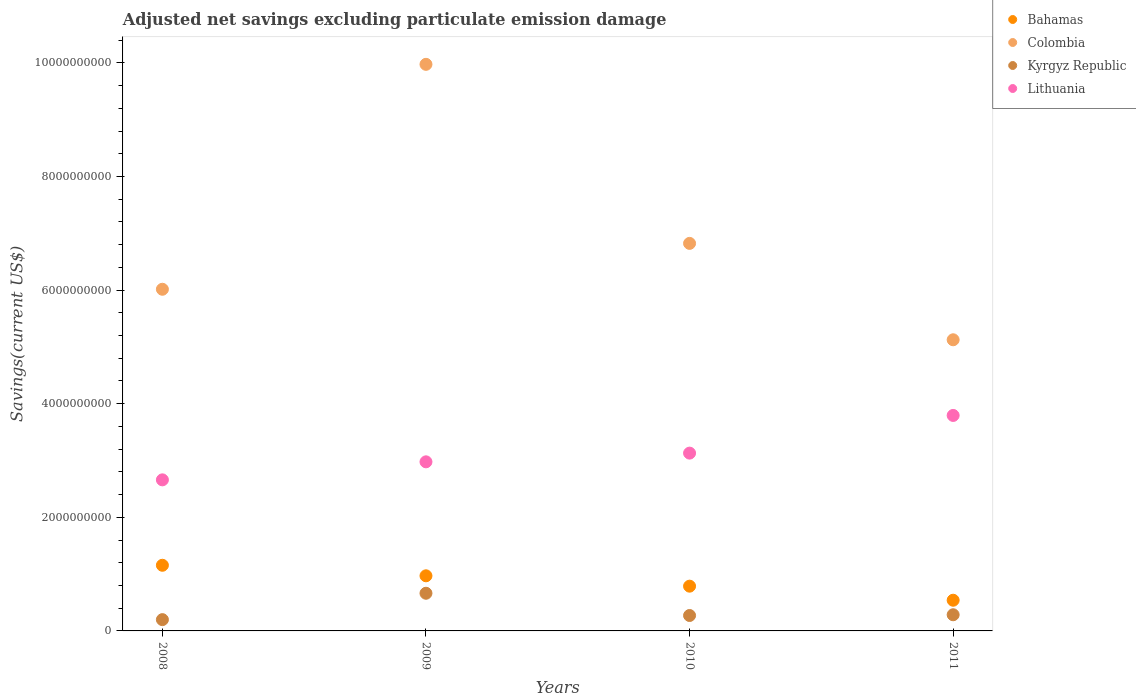What is the adjusted net savings in Lithuania in 2011?
Offer a very short reply. 3.79e+09. Across all years, what is the maximum adjusted net savings in Lithuania?
Give a very brief answer. 3.79e+09. Across all years, what is the minimum adjusted net savings in Kyrgyz Republic?
Ensure brevity in your answer.  1.99e+08. In which year was the adjusted net savings in Lithuania maximum?
Offer a terse response. 2011. What is the total adjusted net savings in Bahamas in the graph?
Make the answer very short. 3.45e+09. What is the difference between the adjusted net savings in Colombia in 2010 and that in 2011?
Offer a very short reply. 1.70e+09. What is the difference between the adjusted net savings in Kyrgyz Republic in 2011 and the adjusted net savings in Colombia in 2010?
Make the answer very short. -6.54e+09. What is the average adjusted net savings in Colombia per year?
Offer a terse response. 6.98e+09. In the year 2011, what is the difference between the adjusted net savings in Lithuania and adjusted net savings in Bahamas?
Make the answer very short. 3.25e+09. What is the ratio of the adjusted net savings in Lithuania in 2009 to that in 2010?
Keep it short and to the point. 0.95. What is the difference between the highest and the second highest adjusted net savings in Colombia?
Your answer should be very brief. 3.15e+09. What is the difference between the highest and the lowest adjusted net savings in Colombia?
Give a very brief answer. 4.85e+09. In how many years, is the adjusted net savings in Bahamas greater than the average adjusted net savings in Bahamas taken over all years?
Make the answer very short. 2. Is it the case that in every year, the sum of the adjusted net savings in Colombia and adjusted net savings in Kyrgyz Republic  is greater than the adjusted net savings in Bahamas?
Offer a very short reply. Yes. Is the adjusted net savings in Kyrgyz Republic strictly greater than the adjusted net savings in Colombia over the years?
Provide a short and direct response. No. How many dotlines are there?
Your response must be concise. 4. How many years are there in the graph?
Provide a succinct answer. 4. Are the values on the major ticks of Y-axis written in scientific E-notation?
Your response must be concise. No. Does the graph contain grids?
Offer a terse response. No. How many legend labels are there?
Offer a very short reply. 4. How are the legend labels stacked?
Offer a terse response. Vertical. What is the title of the graph?
Offer a terse response. Adjusted net savings excluding particulate emission damage. Does "Guam" appear as one of the legend labels in the graph?
Provide a succinct answer. No. What is the label or title of the Y-axis?
Give a very brief answer. Savings(current US$). What is the Savings(current US$) of Bahamas in 2008?
Provide a short and direct response. 1.16e+09. What is the Savings(current US$) of Colombia in 2008?
Provide a short and direct response. 6.01e+09. What is the Savings(current US$) of Kyrgyz Republic in 2008?
Your answer should be very brief. 1.99e+08. What is the Savings(current US$) of Lithuania in 2008?
Give a very brief answer. 2.66e+09. What is the Savings(current US$) in Bahamas in 2009?
Your response must be concise. 9.70e+08. What is the Savings(current US$) in Colombia in 2009?
Keep it short and to the point. 9.97e+09. What is the Savings(current US$) of Kyrgyz Republic in 2009?
Your response must be concise. 6.63e+08. What is the Savings(current US$) in Lithuania in 2009?
Provide a succinct answer. 2.98e+09. What is the Savings(current US$) in Bahamas in 2010?
Your answer should be very brief. 7.88e+08. What is the Savings(current US$) of Colombia in 2010?
Keep it short and to the point. 6.82e+09. What is the Savings(current US$) of Kyrgyz Republic in 2010?
Offer a very short reply. 2.71e+08. What is the Savings(current US$) in Lithuania in 2010?
Give a very brief answer. 3.13e+09. What is the Savings(current US$) of Bahamas in 2011?
Keep it short and to the point. 5.40e+08. What is the Savings(current US$) in Colombia in 2011?
Keep it short and to the point. 5.12e+09. What is the Savings(current US$) in Kyrgyz Republic in 2011?
Your answer should be compact. 2.85e+08. What is the Savings(current US$) of Lithuania in 2011?
Offer a terse response. 3.79e+09. Across all years, what is the maximum Savings(current US$) in Bahamas?
Give a very brief answer. 1.16e+09. Across all years, what is the maximum Savings(current US$) of Colombia?
Ensure brevity in your answer.  9.97e+09. Across all years, what is the maximum Savings(current US$) of Kyrgyz Republic?
Ensure brevity in your answer.  6.63e+08. Across all years, what is the maximum Savings(current US$) of Lithuania?
Ensure brevity in your answer.  3.79e+09. Across all years, what is the minimum Savings(current US$) of Bahamas?
Your answer should be very brief. 5.40e+08. Across all years, what is the minimum Savings(current US$) of Colombia?
Your answer should be compact. 5.12e+09. Across all years, what is the minimum Savings(current US$) of Kyrgyz Republic?
Your answer should be compact. 1.99e+08. Across all years, what is the minimum Savings(current US$) in Lithuania?
Provide a short and direct response. 2.66e+09. What is the total Savings(current US$) in Bahamas in the graph?
Give a very brief answer. 3.45e+09. What is the total Savings(current US$) of Colombia in the graph?
Provide a succinct answer. 2.79e+1. What is the total Savings(current US$) of Kyrgyz Republic in the graph?
Provide a short and direct response. 1.42e+09. What is the total Savings(current US$) of Lithuania in the graph?
Your answer should be very brief. 1.26e+1. What is the difference between the Savings(current US$) in Bahamas in 2008 and that in 2009?
Provide a short and direct response. 1.85e+08. What is the difference between the Savings(current US$) of Colombia in 2008 and that in 2009?
Offer a terse response. -3.96e+09. What is the difference between the Savings(current US$) in Kyrgyz Republic in 2008 and that in 2009?
Make the answer very short. -4.65e+08. What is the difference between the Savings(current US$) of Lithuania in 2008 and that in 2009?
Provide a short and direct response. -3.17e+08. What is the difference between the Savings(current US$) of Bahamas in 2008 and that in 2010?
Keep it short and to the point. 3.68e+08. What is the difference between the Savings(current US$) in Colombia in 2008 and that in 2010?
Your answer should be compact. -8.08e+08. What is the difference between the Savings(current US$) of Kyrgyz Republic in 2008 and that in 2010?
Your answer should be compact. -7.28e+07. What is the difference between the Savings(current US$) in Lithuania in 2008 and that in 2010?
Your answer should be very brief. -4.70e+08. What is the difference between the Savings(current US$) of Bahamas in 2008 and that in 2011?
Offer a terse response. 6.15e+08. What is the difference between the Savings(current US$) in Colombia in 2008 and that in 2011?
Make the answer very short. 8.89e+08. What is the difference between the Savings(current US$) of Kyrgyz Republic in 2008 and that in 2011?
Provide a short and direct response. -8.60e+07. What is the difference between the Savings(current US$) in Lithuania in 2008 and that in 2011?
Give a very brief answer. -1.13e+09. What is the difference between the Savings(current US$) in Bahamas in 2009 and that in 2010?
Your response must be concise. 1.82e+08. What is the difference between the Savings(current US$) in Colombia in 2009 and that in 2010?
Give a very brief answer. 3.15e+09. What is the difference between the Savings(current US$) in Kyrgyz Republic in 2009 and that in 2010?
Your answer should be compact. 3.92e+08. What is the difference between the Savings(current US$) of Lithuania in 2009 and that in 2010?
Provide a short and direct response. -1.53e+08. What is the difference between the Savings(current US$) of Bahamas in 2009 and that in 2011?
Provide a succinct answer. 4.30e+08. What is the difference between the Savings(current US$) of Colombia in 2009 and that in 2011?
Your response must be concise. 4.85e+09. What is the difference between the Savings(current US$) of Kyrgyz Republic in 2009 and that in 2011?
Provide a short and direct response. 3.78e+08. What is the difference between the Savings(current US$) of Lithuania in 2009 and that in 2011?
Make the answer very short. -8.17e+08. What is the difference between the Savings(current US$) in Bahamas in 2010 and that in 2011?
Keep it short and to the point. 2.48e+08. What is the difference between the Savings(current US$) of Colombia in 2010 and that in 2011?
Keep it short and to the point. 1.70e+09. What is the difference between the Savings(current US$) in Kyrgyz Republic in 2010 and that in 2011?
Provide a succinct answer. -1.32e+07. What is the difference between the Savings(current US$) in Lithuania in 2010 and that in 2011?
Provide a succinct answer. -6.63e+08. What is the difference between the Savings(current US$) of Bahamas in 2008 and the Savings(current US$) of Colombia in 2009?
Give a very brief answer. -8.82e+09. What is the difference between the Savings(current US$) of Bahamas in 2008 and the Savings(current US$) of Kyrgyz Republic in 2009?
Give a very brief answer. 4.93e+08. What is the difference between the Savings(current US$) in Bahamas in 2008 and the Savings(current US$) in Lithuania in 2009?
Give a very brief answer. -1.82e+09. What is the difference between the Savings(current US$) in Colombia in 2008 and the Savings(current US$) in Kyrgyz Republic in 2009?
Provide a short and direct response. 5.35e+09. What is the difference between the Savings(current US$) in Colombia in 2008 and the Savings(current US$) in Lithuania in 2009?
Provide a succinct answer. 3.04e+09. What is the difference between the Savings(current US$) of Kyrgyz Republic in 2008 and the Savings(current US$) of Lithuania in 2009?
Your answer should be very brief. -2.78e+09. What is the difference between the Savings(current US$) of Bahamas in 2008 and the Savings(current US$) of Colombia in 2010?
Ensure brevity in your answer.  -5.67e+09. What is the difference between the Savings(current US$) in Bahamas in 2008 and the Savings(current US$) in Kyrgyz Republic in 2010?
Make the answer very short. 8.84e+08. What is the difference between the Savings(current US$) in Bahamas in 2008 and the Savings(current US$) in Lithuania in 2010?
Offer a very short reply. -1.97e+09. What is the difference between the Savings(current US$) of Colombia in 2008 and the Savings(current US$) of Kyrgyz Republic in 2010?
Provide a succinct answer. 5.74e+09. What is the difference between the Savings(current US$) in Colombia in 2008 and the Savings(current US$) in Lithuania in 2010?
Your answer should be very brief. 2.88e+09. What is the difference between the Savings(current US$) of Kyrgyz Republic in 2008 and the Savings(current US$) of Lithuania in 2010?
Offer a terse response. -2.93e+09. What is the difference between the Savings(current US$) of Bahamas in 2008 and the Savings(current US$) of Colombia in 2011?
Give a very brief answer. -3.97e+09. What is the difference between the Savings(current US$) of Bahamas in 2008 and the Savings(current US$) of Kyrgyz Republic in 2011?
Offer a very short reply. 8.71e+08. What is the difference between the Savings(current US$) of Bahamas in 2008 and the Savings(current US$) of Lithuania in 2011?
Provide a succinct answer. -2.64e+09. What is the difference between the Savings(current US$) in Colombia in 2008 and the Savings(current US$) in Kyrgyz Republic in 2011?
Offer a very short reply. 5.73e+09. What is the difference between the Savings(current US$) of Colombia in 2008 and the Savings(current US$) of Lithuania in 2011?
Keep it short and to the point. 2.22e+09. What is the difference between the Savings(current US$) of Kyrgyz Republic in 2008 and the Savings(current US$) of Lithuania in 2011?
Offer a terse response. -3.59e+09. What is the difference between the Savings(current US$) of Bahamas in 2009 and the Savings(current US$) of Colombia in 2010?
Offer a terse response. -5.85e+09. What is the difference between the Savings(current US$) of Bahamas in 2009 and the Savings(current US$) of Kyrgyz Republic in 2010?
Make the answer very short. 6.99e+08. What is the difference between the Savings(current US$) in Bahamas in 2009 and the Savings(current US$) in Lithuania in 2010?
Provide a short and direct response. -2.16e+09. What is the difference between the Savings(current US$) in Colombia in 2009 and the Savings(current US$) in Kyrgyz Republic in 2010?
Offer a terse response. 9.70e+09. What is the difference between the Savings(current US$) in Colombia in 2009 and the Savings(current US$) in Lithuania in 2010?
Your answer should be very brief. 6.84e+09. What is the difference between the Savings(current US$) of Kyrgyz Republic in 2009 and the Savings(current US$) of Lithuania in 2010?
Offer a terse response. -2.47e+09. What is the difference between the Savings(current US$) of Bahamas in 2009 and the Savings(current US$) of Colombia in 2011?
Your answer should be compact. -4.15e+09. What is the difference between the Savings(current US$) of Bahamas in 2009 and the Savings(current US$) of Kyrgyz Republic in 2011?
Keep it short and to the point. 6.86e+08. What is the difference between the Savings(current US$) in Bahamas in 2009 and the Savings(current US$) in Lithuania in 2011?
Offer a very short reply. -2.82e+09. What is the difference between the Savings(current US$) in Colombia in 2009 and the Savings(current US$) in Kyrgyz Republic in 2011?
Provide a succinct answer. 9.69e+09. What is the difference between the Savings(current US$) of Colombia in 2009 and the Savings(current US$) of Lithuania in 2011?
Keep it short and to the point. 6.18e+09. What is the difference between the Savings(current US$) of Kyrgyz Republic in 2009 and the Savings(current US$) of Lithuania in 2011?
Provide a succinct answer. -3.13e+09. What is the difference between the Savings(current US$) in Bahamas in 2010 and the Savings(current US$) in Colombia in 2011?
Offer a very short reply. -4.34e+09. What is the difference between the Savings(current US$) of Bahamas in 2010 and the Savings(current US$) of Kyrgyz Republic in 2011?
Your answer should be compact. 5.03e+08. What is the difference between the Savings(current US$) in Bahamas in 2010 and the Savings(current US$) in Lithuania in 2011?
Your response must be concise. -3.01e+09. What is the difference between the Savings(current US$) of Colombia in 2010 and the Savings(current US$) of Kyrgyz Republic in 2011?
Offer a terse response. 6.54e+09. What is the difference between the Savings(current US$) in Colombia in 2010 and the Savings(current US$) in Lithuania in 2011?
Your answer should be very brief. 3.03e+09. What is the difference between the Savings(current US$) of Kyrgyz Republic in 2010 and the Savings(current US$) of Lithuania in 2011?
Your answer should be compact. -3.52e+09. What is the average Savings(current US$) in Bahamas per year?
Make the answer very short. 8.63e+08. What is the average Savings(current US$) in Colombia per year?
Your response must be concise. 6.98e+09. What is the average Savings(current US$) of Kyrgyz Republic per year?
Your answer should be compact. 3.54e+08. What is the average Savings(current US$) in Lithuania per year?
Provide a succinct answer. 3.14e+09. In the year 2008, what is the difference between the Savings(current US$) of Bahamas and Savings(current US$) of Colombia?
Your answer should be very brief. -4.86e+09. In the year 2008, what is the difference between the Savings(current US$) in Bahamas and Savings(current US$) in Kyrgyz Republic?
Make the answer very short. 9.57e+08. In the year 2008, what is the difference between the Savings(current US$) in Bahamas and Savings(current US$) in Lithuania?
Your response must be concise. -1.50e+09. In the year 2008, what is the difference between the Savings(current US$) in Colombia and Savings(current US$) in Kyrgyz Republic?
Offer a terse response. 5.82e+09. In the year 2008, what is the difference between the Savings(current US$) in Colombia and Savings(current US$) in Lithuania?
Your answer should be compact. 3.35e+09. In the year 2008, what is the difference between the Savings(current US$) of Kyrgyz Republic and Savings(current US$) of Lithuania?
Your response must be concise. -2.46e+09. In the year 2009, what is the difference between the Savings(current US$) in Bahamas and Savings(current US$) in Colombia?
Make the answer very short. -9.00e+09. In the year 2009, what is the difference between the Savings(current US$) in Bahamas and Savings(current US$) in Kyrgyz Republic?
Ensure brevity in your answer.  3.07e+08. In the year 2009, what is the difference between the Savings(current US$) in Bahamas and Savings(current US$) in Lithuania?
Make the answer very short. -2.01e+09. In the year 2009, what is the difference between the Savings(current US$) in Colombia and Savings(current US$) in Kyrgyz Republic?
Ensure brevity in your answer.  9.31e+09. In the year 2009, what is the difference between the Savings(current US$) in Colombia and Savings(current US$) in Lithuania?
Offer a very short reply. 7.00e+09. In the year 2009, what is the difference between the Savings(current US$) in Kyrgyz Republic and Savings(current US$) in Lithuania?
Ensure brevity in your answer.  -2.31e+09. In the year 2010, what is the difference between the Savings(current US$) in Bahamas and Savings(current US$) in Colombia?
Offer a terse response. -6.03e+09. In the year 2010, what is the difference between the Savings(current US$) in Bahamas and Savings(current US$) in Kyrgyz Republic?
Give a very brief answer. 5.16e+08. In the year 2010, what is the difference between the Savings(current US$) of Bahamas and Savings(current US$) of Lithuania?
Make the answer very short. -2.34e+09. In the year 2010, what is the difference between the Savings(current US$) of Colombia and Savings(current US$) of Kyrgyz Republic?
Keep it short and to the point. 6.55e+09. In the year 2010, what is the difference between the Savings(current US$) of Colombia and Savings(current US$) of Lithuania?
Offer a very short reply. 3.69e+09. In the year 2010, what is the difference between the Savings(current US$) of Kyrgyz Republic and Savings(current US$) of Lithuania?
Offer a very short reply. -2.86e+09. In the year 2011, what is the difference between the Savings(current US$) of Bahamas and Savings(current US$) of Colombia?
Your answer should be very brief. -4.58e+09. In the year 2011, what is the difference between the Savings(current US$) in Bahamas and Savings(current US$) in Kyrgyz Republic?
Make the answer very short. 2.56e+08. In the year 2011, what is the difference between the Savings(current US$) in Bahamas and Savings(current US$) in Lithuania?
Your answer should be very brief. -3.25e+09. In the year 2011, what is the difference between the Savings(current US$) of Colombia and Savings(current US$) of Kyrgyz Republic?
Provide a succinct answer. 4.84e+09. In the year 2011, what is the difference between the Savings(current US$) of Colombia and Savings(current US$) of Lithuania?
Your answer should be very brief. 1.33e+09. In the year 2011, what is the difference between the Savings(current US$) in Kyrgyz Republic and Savings(current US$) in Lithuania?
Your response must be concise. -3.51e+09. What is the ratio of the Savings(current US$) in Bahamas in 2008 to that in 2009?
Your answer should be compact. 1.19. What is the ratio of the Savings(current US$) of Colombia in 2008 to that in 2009?
Your response must be concise. 0.6. What is the ratio of the Savings(current US$) in Kyrgyz Republic in 2008 to that in 2009?
Provide a short and direct response. 0.3. What is the ratio of the Savings(current US$) in Lithuania in 2008 to that in 2009?
Make the answer very short. 0.89. What is the ratio of the Savings(current US$) of Bahamas in 2008 to that in 2010?
Provide a succinct answer. 1.47. What is the ratio of the Savings(current US$) in Colombia in 2008 to that in 2010?
Ensure brevity in your answer.  0.88. What is the ratio of the Savings(current US$) of Kyrgyz Republic in 2008 to that in 2010?
Give a very brief answer. 0.73. What is the ratio of the Savings(current US$) in Lithuania in 2008 to that in 2010?
Give a very brief answer. 0.85. What is the ratio of the Savings(current US$) of Bahamas in 2008 to that in 2011?
Ensure brevity in your answer.  2.14. What is the ratio of the Savings(current US$) of Colombia in 2008 to that in 2011?
Your answer should be compact. 1.17. What is the ratio of the Savings(current US$) in Kyrgyz Republic in 2008 to that in 2011?
Keep it short and to the point. 0.7. What is the ratio of the Savings(current US$) in Lithuania in 2008 to that in 2011?
Keep it short and to the point. 0.7. What is the ratio of the Savings(current US$) of Bahamas in 2009 to that in 2010?
Your response must be concise. 1.23. What is the ratio of the Savings(current US$) in Colombia in 2009 to that in 2010?
Make the answer very short. 1.46. What is the ratio of the Savings(current US$) in Kyrgyz Republic in 2009 to that in 2010?
Your answer should be compact. 2.44. What is the ratio of the Savings(current US$) in Lithuania in 2009 to that in 2010?
Provide a succinct answer. 0.95. What is the ratio of the Savings(current US$) in Bahamas in 2009 to that in 2011?
Provide a succinct answer. 1.8. What is the ratio of the Savings(current US$) of Colombia in 2009 to that in 2011?
Your answer should be very brief. 1.95. What is the ratio of the Savings(current US$) in Kyrgyz Republic in 2009 to that in 2011?
Ensure brevity in your answer.  2.33. What is the ratio of the Savings(current US$) of Lithuania in 2009 to that in 2011?
Your answer should be compact. 0.78. What is the ratio of the Savings(current US$) in Bahamas in 2010 to that in 2011?
Your answer should be compact. 1.46. What is the ratio of the Savings(current US$) of Colombia in 2010 to that in 2011?
Offer a terse response. 1.33. What is the ratio of the Savings(current US$) in Kyrgyz Republic in 2010 to that in 2011?
Make the answer very short. 0.95. What is the ratio of the Savings(current US$) of Lithuania in 2010 to that in 2011?
Give a very brief answer. 0.83. What is the difference between the highest and the second highest Savings(current US$) of Bahamas?
Keep it short and to the point. 1.85e+08. What is the difference between the highest and the second highest Savings(current US$) of Colombia?
Your answer should be very brief. 3.15e+09. What is the difference between the highest and the second highest Savings(current US$) in Kyrgyz Republic?
Keep it short and to the point. 3.78e+08. What is the difference between the highest and the second highest Savings(current US$) in Lithuania?
Offer a terse response. 6.63e+08. What is the difference between the highest and the lowest Savings(current US$) of Bahamas?
Your answer should be compact. 6.15e+08. What is the difference between the highest and the lowest Savings(current US$) of Colombia?
Offer a very short reply. 4.85e+09. What is the difference between the highest and the lowest Savings(current US$) in Kyrgyz Republic?
Offer a terse response. 4.65e+08. What is the difference between the highest and the lowest Savings(current US$) of Lithuania?
Keep it short and to the point. 1.13e+09. 